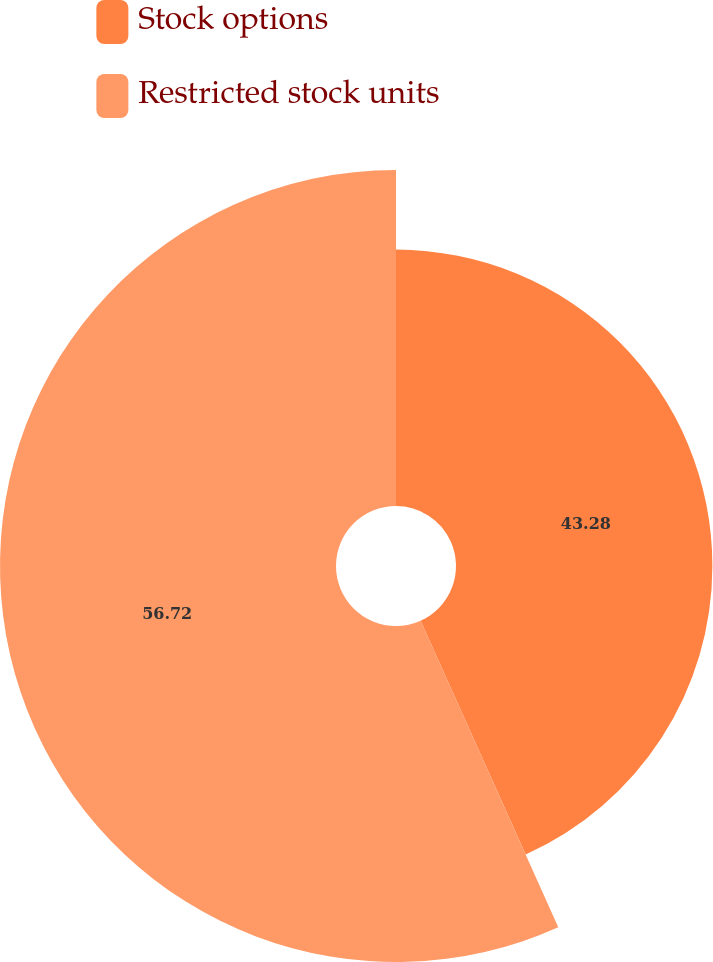Convert chart. <chart><loc_0><loc_0><loc_500><loc_500><pie_chart><fcel>Stock options<fcel>Restricted stock units<nl><fcel>43.28%<fcel>56.72%<nl></chart> 